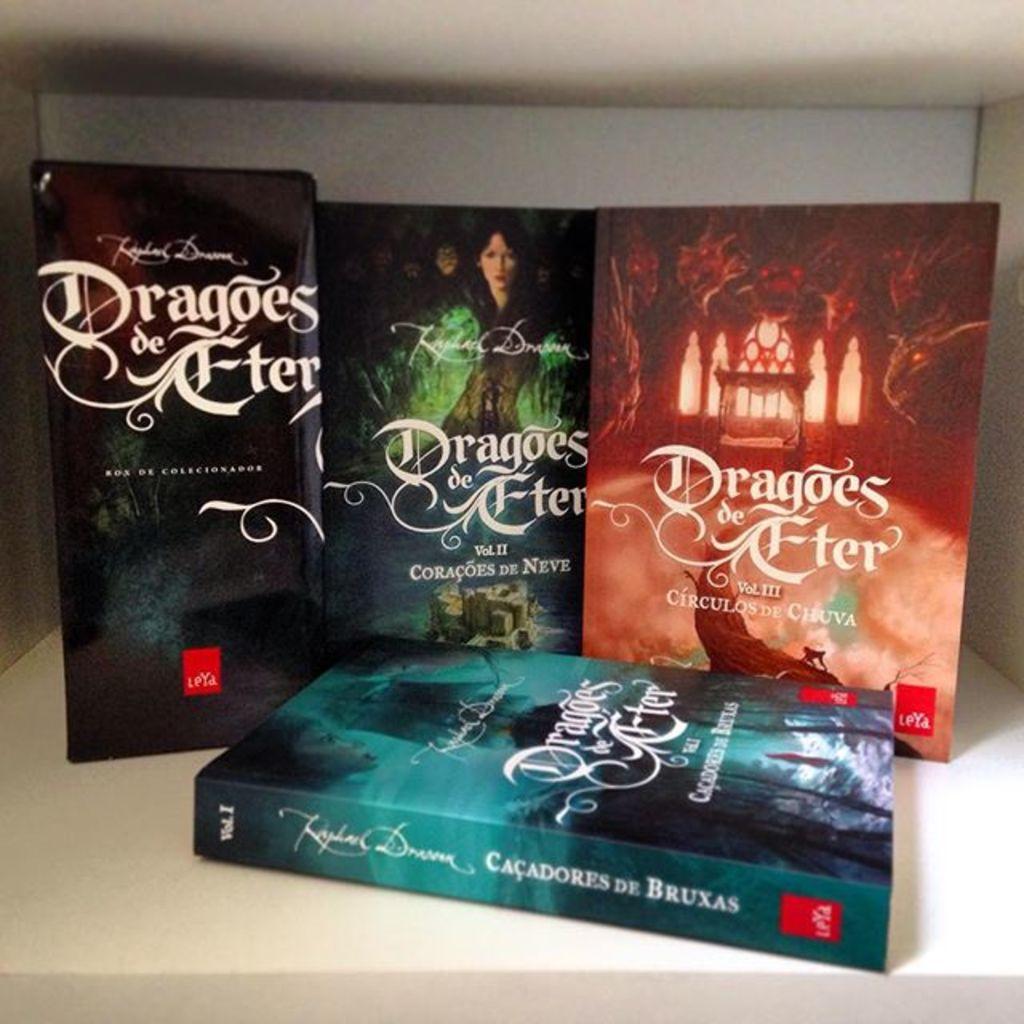What volume number is the book on the right?
Your response must be concise. Iii. 